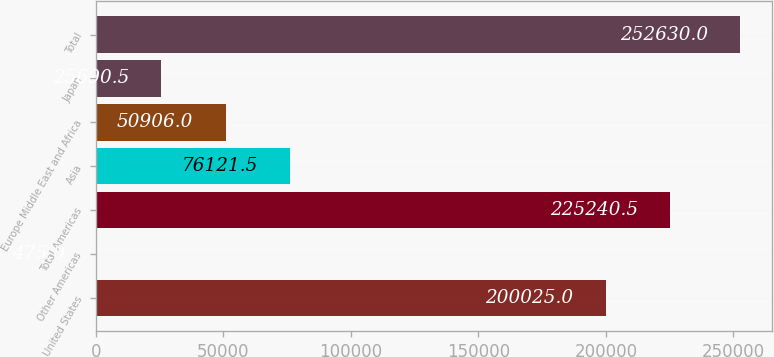Convert chart to OTSL. <chart><loc_0><loc_0><loc_500><loc_500><bar_chart><fcel>United States<fcel>Other Americas<fcel>Total Americas<fcel>Asia<fcel>Europe Middle East and Africa<fcel>Japan<fcel>Total<nl><fcel>200025<fcel>475<fcel>225240<fcel>76121.5<fcel>50906<fcel>25690.5<fcel>252630<nl></chart> 